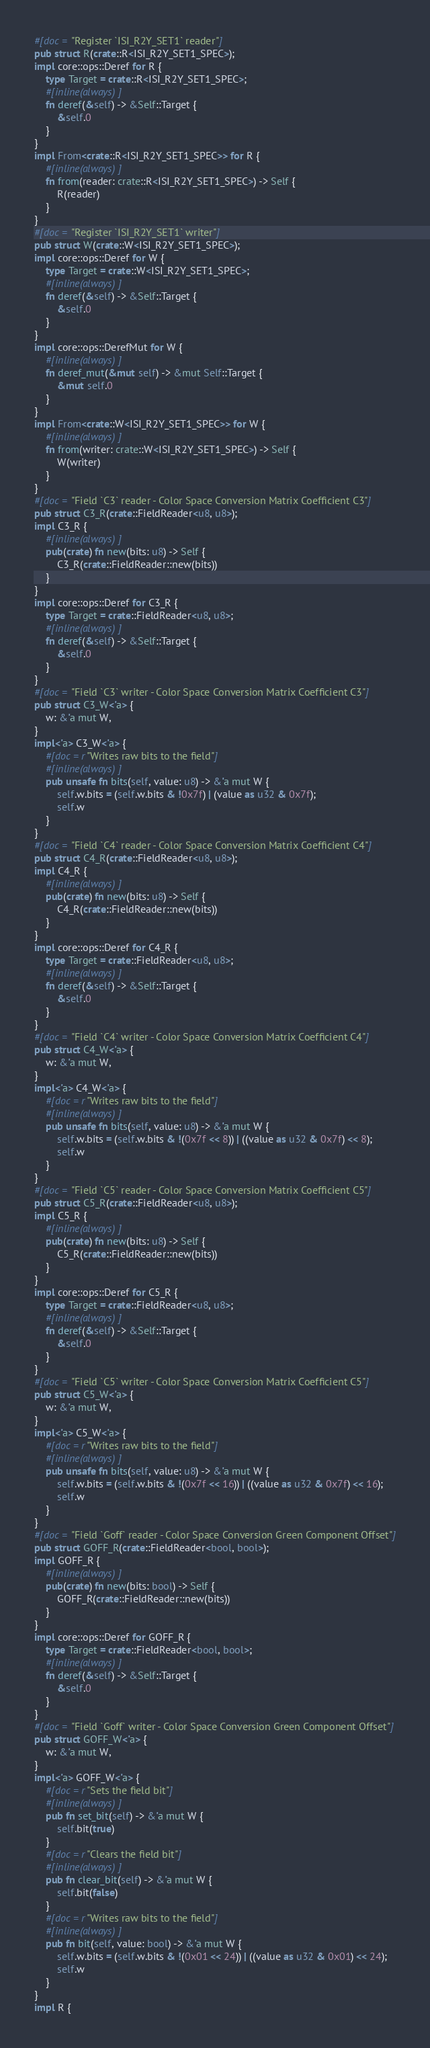Convert code to text. <code><loc_0><loc_0><loc_500><loc_500><_Rust_>#[doc = "Register `ISI_R2Y_SET1` reader"]
pub struct R(crate::R<ISI_R2Y_SET1_SPEC>);
impl core::ops::Deref for R {
    type Target = crate::R<ISI_R2Y_SET1_SPEC>;
    #[inline(always)]
    fn deref(&self) -> &Self::Target {
        &self.0
    }
}
impl From<crate::R<ISI_R2Y_SET1_SPEC>> for R {
    #[inline(always)]
    fn from(reader: crate::R<ISI_R2Y_SET1_SPEC>) -> Self {
        R(reader)
    }
}
#[doc = "Register `ISI_R2Y_SET1` writer"]
pub struct W(crate::W<ISI_R2Y_SET1_SPEC>);
impl core::ops::Deref for W {
    type Target = crate::W<ISI_R2Y_SET1_SPEC>;
    #[inline(always)]
    fn deref(&self) -> &Self::Target {
        &self.0
    }
}
impl core::ops::DerefMut for W {
    #[inline(always)]
    fn deref_mut(&mut self) -> &mut Self::Target {
        &mut self.0
    }
}
impl From<crate::W<ISI_R2Y_SET1_SPEC>> for W {
    #[inline(always)]
    fn from(writer: crate::W<ISI_R2Y_SET1_SPEC>) -> Self {
        W(writer)
    }
}
#[doc = "Field `C3` reader - Color Space Conversion Matrix Coefficient C3"]
pub struct C3_R(crate::FieldReader<u8, u8>);
impl C3_R {
    #[inline(always)]
    pub(crate) fn new(bits: u8) -> Self {
        C3_R(crate::FieldReader::new(bits))
    }
}
impl core::ops::Deref for C3_R {
    type Target = crate::FieldReader<u8, u8>;
    #[inline(always)]
    fn deref(&self) -> &Self::Target {
        &self.0
    }
}
#[doc = "Field `C3` writer - Color Space Conversion Matrix Coefficient C3"]
pub struct C3_W<'a> {
    w: &'a mut W,
}
impl<'a> C3_W<'a> {
    #[doc = r"Writes raw bits to the field"]
    #[inline(always)]
    pub unsafe fn bits(self, value: u8) -> &'a mut W {
        self.w.bits = (self.w.bits & !0x7f) | (value as u32 & 0x7f);
        self.w
    }
}
#[doc = "Field `C4` reader - Color Space Conversion Matrix Coefficient C4"]
pub struct C4_R(crate::FieldReader<u8, u8>);
impl C4_R {
    #[inline(always)]
    pub(crate) fn new(bits: u8) -> Self {
        C4_R(crate::FieldReader::new(bits))
    }
}
impl core::ops::Deref for C4_R {
    type Target = crate::FieldReader<u8, u8>;
    #[inline(always)]
    fn deref(&self) -> &Self::Target {
        &self.0
    }
}
#[doc = "Field `C4` writer - Color Space Conversion Matrix Coefficient C4"]
pub struct C4_W<'a> {
    w: &'a mut W,
}
impl<'a> C4_W<'a> {
    #[doc = r"Writes raw bits to the field"]
    #[inline(always)]
    pub unsafe fn bits(self, value: u8) -> &'a mut W {
        self.w.bits = (self.w.bits & !(0x7f << 8)) | ((value as u32 & 0x7f) << 8);
        self.w
    }
}
#[doc = "Field `C5` reader - Color Space Conversion Matrix Coefficient C5"]
pub struct C5_R(crate::FieldReader<u8, u8>);
impl C5_R {
    #[inline(always)]
    pub(crate) fn new(bits: u8) -> Self {
        C5_R(crate::FieldReader::new(bits))
    }
}
impl core::ops::Deref for C5_R {
    type Target = crate::FieldReader<u8, u8>;
    #[inline(always)]
    fn deref(&self) -> &Self::Target {
        &self.0
    }
}
#[doc = "Field `C5` writer - Color Space Conversion Matrix Coefficient C5"]
pub struct C5_W<'a> {
    w: &'a mut W,
}
impl<'a> C5_W<'a> {
    #[doc = r"Writes raw bits to the field"]
    #[inline(always)]
    pub unsafe fn bits(self, value: u8) -> &'a mut W {
        self.w.bits = (self.w.bits & !(0x7f << 16)) | ((value as u32 & 0x7f) << 16);
        self.w
    }
}
#[doc = "Field `Goff` reader - Color Space Conversion Green Component Offset"]
pub struct GOFF_R(crate::FieldReader<bool, bool>);
impl GOFF_R {
    #[inline(always)]
    pub(crate) fn new(bits: bool) -> Self {
        GOFF_R(crate::FieldReader::new(bits))
    }
}
impl core::ops::Deref for GOFF_R {
    type Target = crate::FieldReader<bool, bool>;
    #[inline(always)]
    fn deref(&self) -> &Self::Target {
        &self.0
    }
}
#[doc = "Field `Goff` writer - Color Space Conversion Green Component Offset"]
pub struct GOFF_W<'a> {
    w: &'a mut W,
}
impl<'a> GOFF_W<'a> {
    #[doc = r"Sets the field bit"]
    #[inline(always)]
    pub fn set_bit(self) -> &'a mut W {
        self.bit(true)
    }
    #[doc = r"Clears the field bit"]
    #[inline(always)]
    pub fn clear_bit(self) -> &'a mut W {
        self.bit(false)
    }
    #[doc = r"Writes raw bits to the field"]
    #[inline(always)]
    pub fn bit(self, value: bool) -> &'a mut W {
        self.w.bits = (self.w.bits & !(0x01 << 24)) | ((value as u32 & 0x01) << 24);
        self.w
    }
}
impl R {</code> 